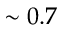<formula> <loc_0><loc_0><loc_500><loc_500>\sim 0 . 7</formula> 